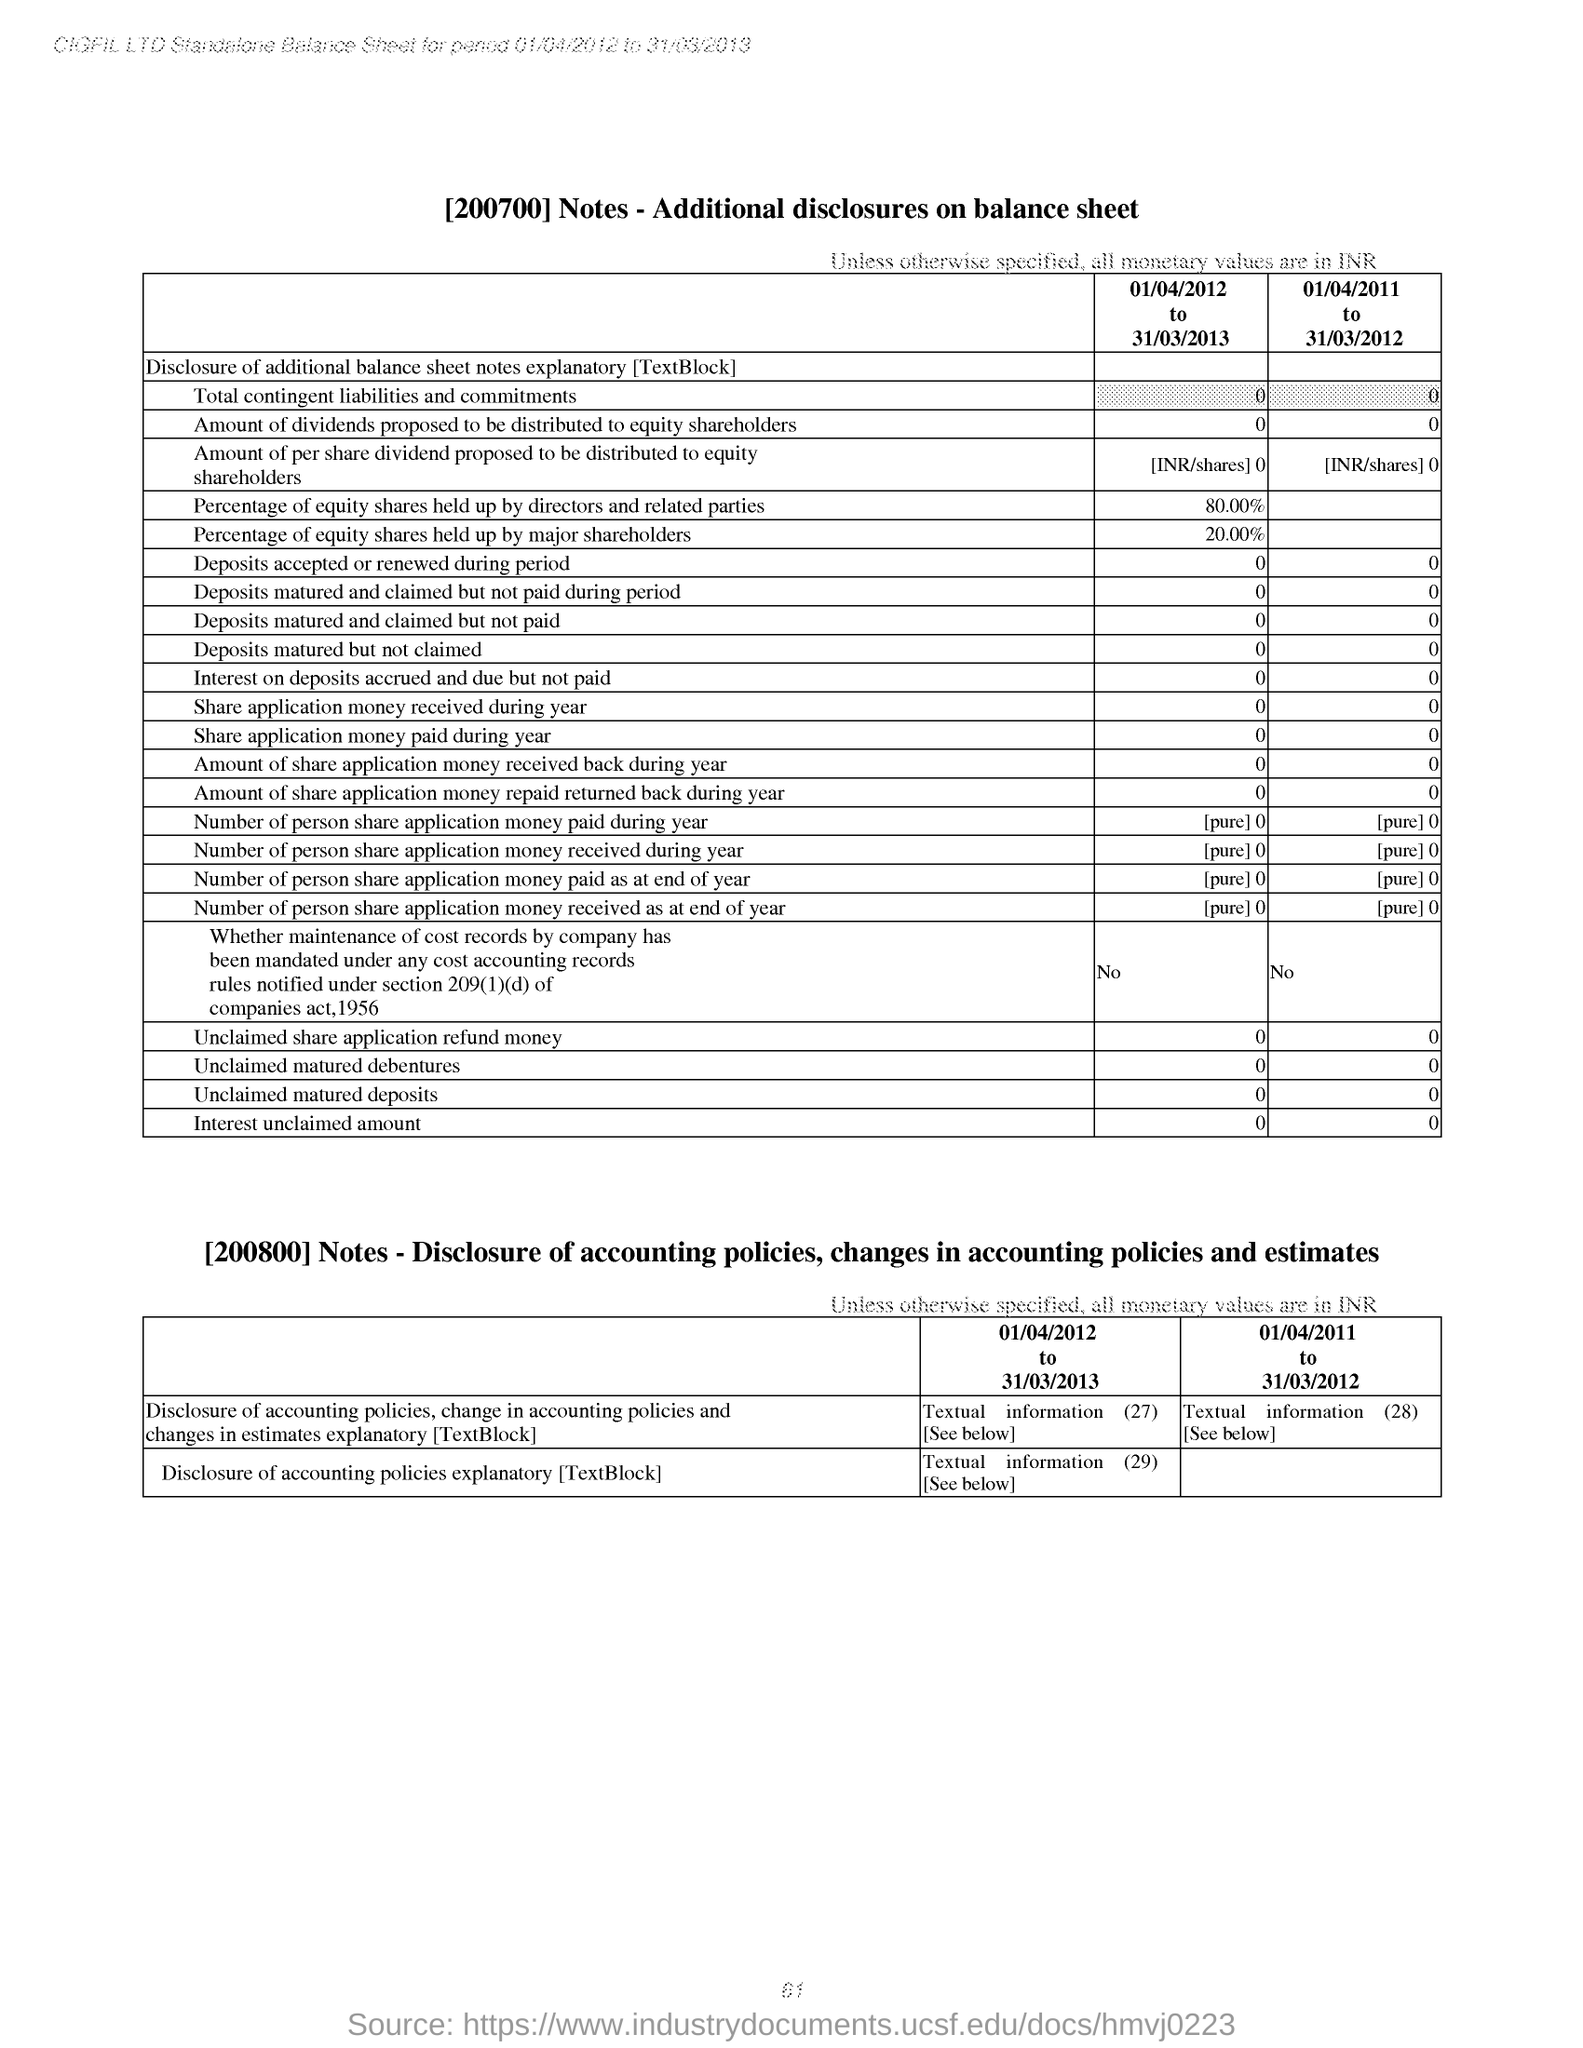What is the title of the first table?
Offer a very short reply. [200700] Notes - Additional disclosures on balance sheet. What is the Percentage of equity shares held up by major shareholders from 01/04/2012 to 31/03/2013??
Offer a terse response. 20.00%. 